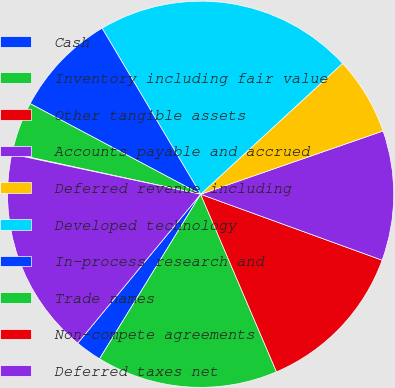Convert chart to OTSL. <chart><loc_0><loc_0><loc_500><loc_500><pie_chart><fcel>Cash<fcel>Inventory including fair value<fcel>Other tangible assets<fcel>Accounts payable and accrued<fcel>Deferred revenue including<fcel>Developed technology<fcel>In-process research and<fcel>Trade names<fcel>Non-compete agreements<fcel>Deferred taxes net<nl><fcel>2.22%<fcel>15.19%<fcel>13.03%<fcel>10.86%<fcel>6.54%<fcel>21.67%<fcel>8.7%<fcel>4.38%<fcel>0.06%<fcel>17.35%<nl></chart> 